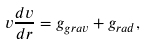Convert formula to latex. <formula><loc_0><loc_0><loc_500><loc_500>v \frac { d v } { d r } = g _ { g r a v } + g _ { r a d } ,</formula> 